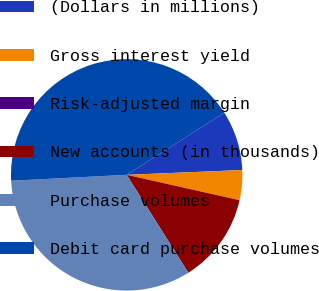<chart> <loc_0><loc_0><loc_500><loc_500><pie_chart><fcel>(Dollars in millions)<fcel>Gross interest yield<fcel>Risk-adjusted margin<fcel>New accounts (in thousands)<fcel>Purchase volumes<fcel>Debit card purchase volumes<nl><fcel>8.36%<fcel>4.18%<fcel>0.0%<fcel>12.54%<fcel>33.13%<fcel>41.79%<nl></chart> 